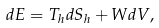Convert formula to latex. <formula><loc_0><loc_0><loc_500><loc_500>d E = T _ { h } d S _ { h } + W d V ,</formula> 